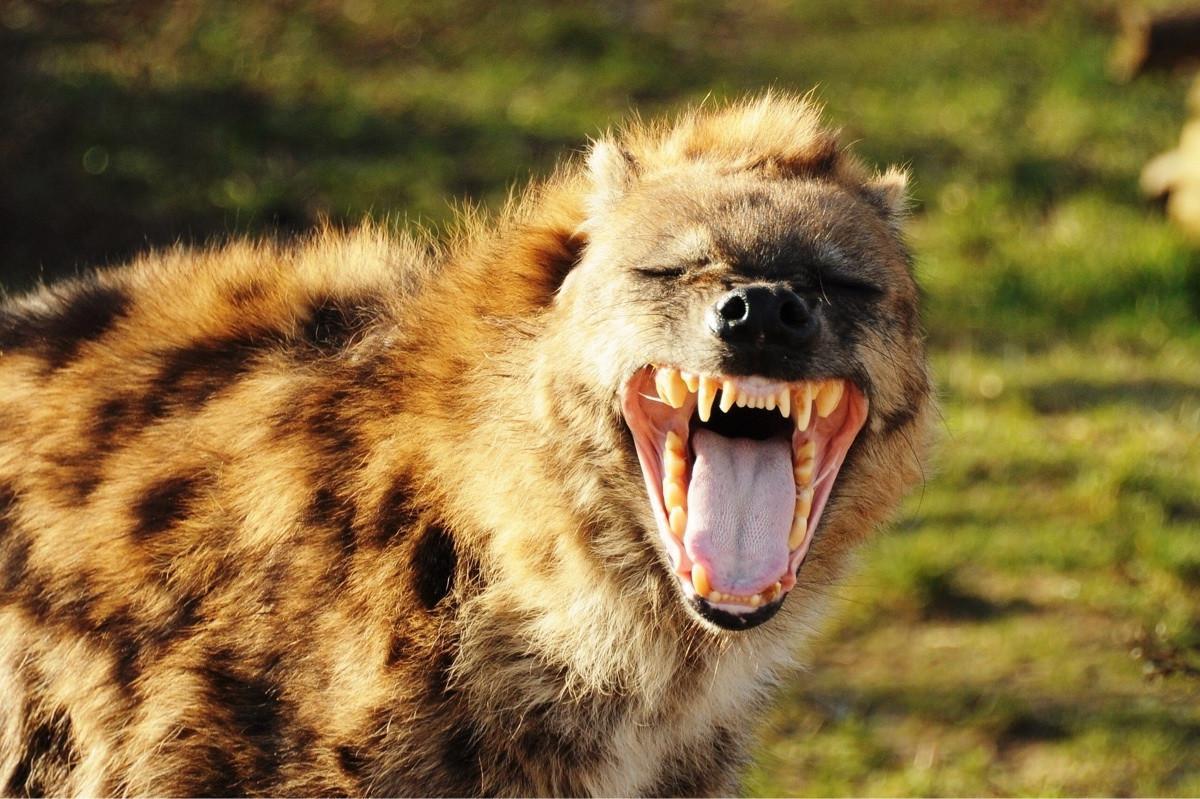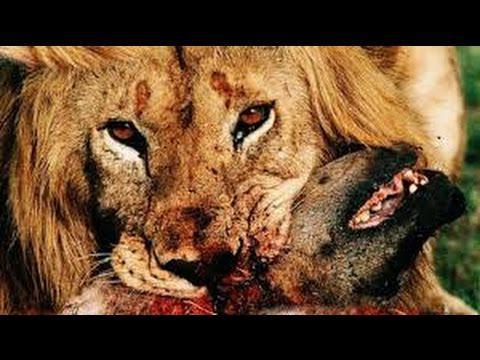The first image is the image on the left, the second image is the image on the right. Considering the images on both sides, is "The left image contains no more than one hyena." valid? Answer yes or no. Yes. The first image is the image on the left, the second image is the image on the right. Evaluate the accuracy of this statement regarding the images: "There is a species other than a hyena in at least one of the images.". Is it true? Answer yes or no. Yes. 